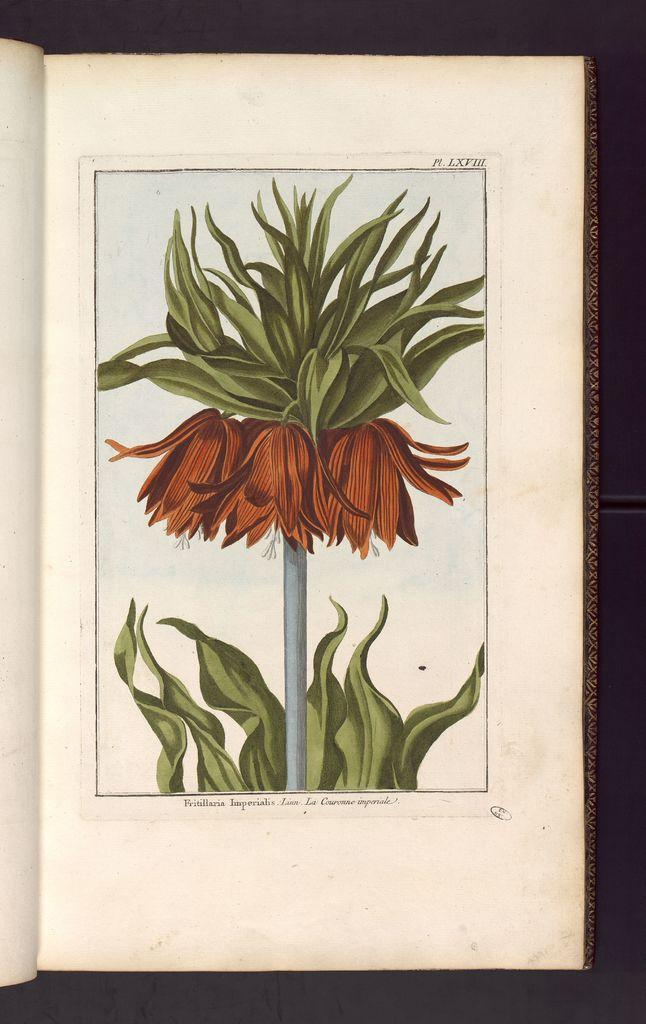What is the main subject of the image? The main subject of the image is a book. Can you describe the book's appearance? The book has a drawing of a flower and plant on it, and it also has text. What is the color of the background in the image? The background of the image is black. What type of weather can be seen in the image? There is no weather depicted in the image, as it features a book with a drawing of a flower and plant on a black background. Can you tell me how many people are running in the image? There are no people or running depicted in the image, as it features a book with a drawing of a flower and plant on a black background. 